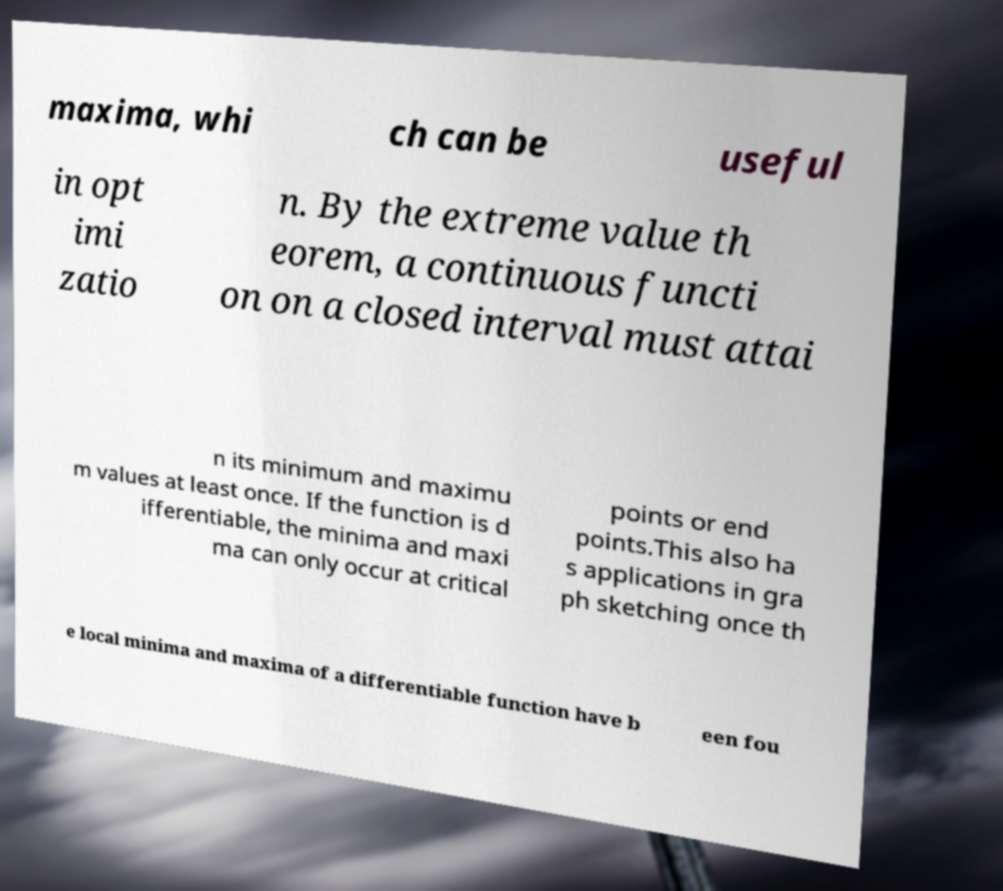Please identify and transcribe the text found in this image. maxima, whi ch can be useful in opt imi zatio n. By the extreme value th eorem, a continuous functi on on a closed interval must attai n its minimum and maximu m values at least once. If the function is d ifferentiable, the minima and maxi ma can only occur at critical points or end points.This also ha s applications in gra ph sketching once th e local minima and maxima of a differentiable function have b een fou 